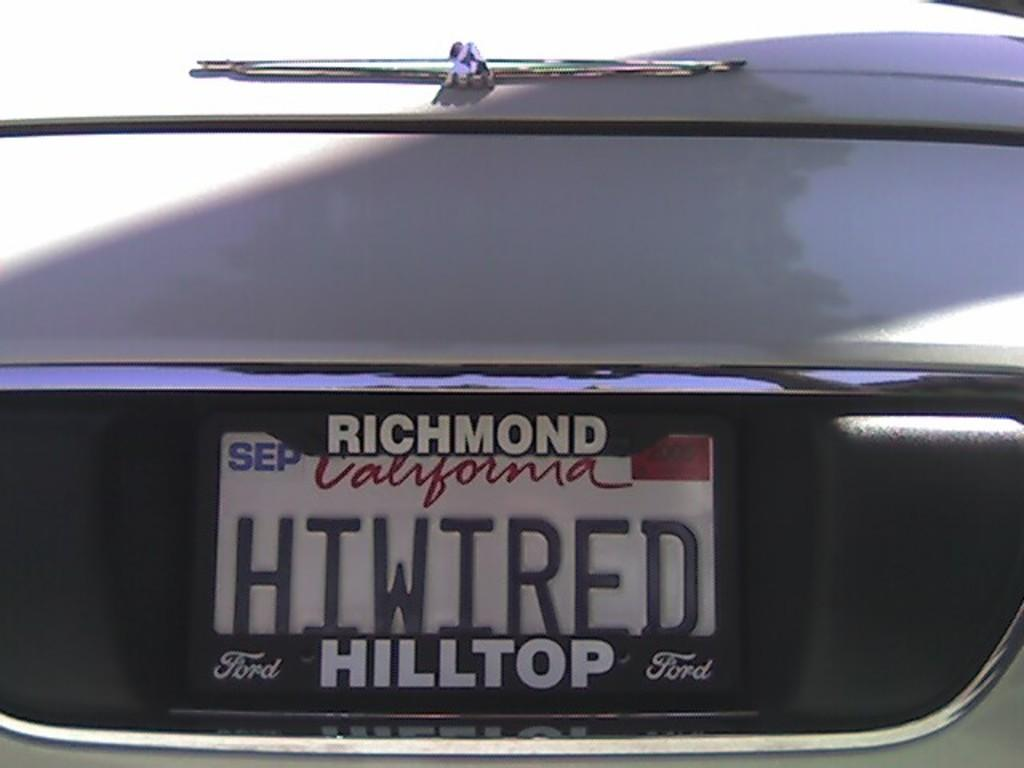<image>
Create a compact narrative representing the image presented. The California license plate is stamped with HIWIRED. 